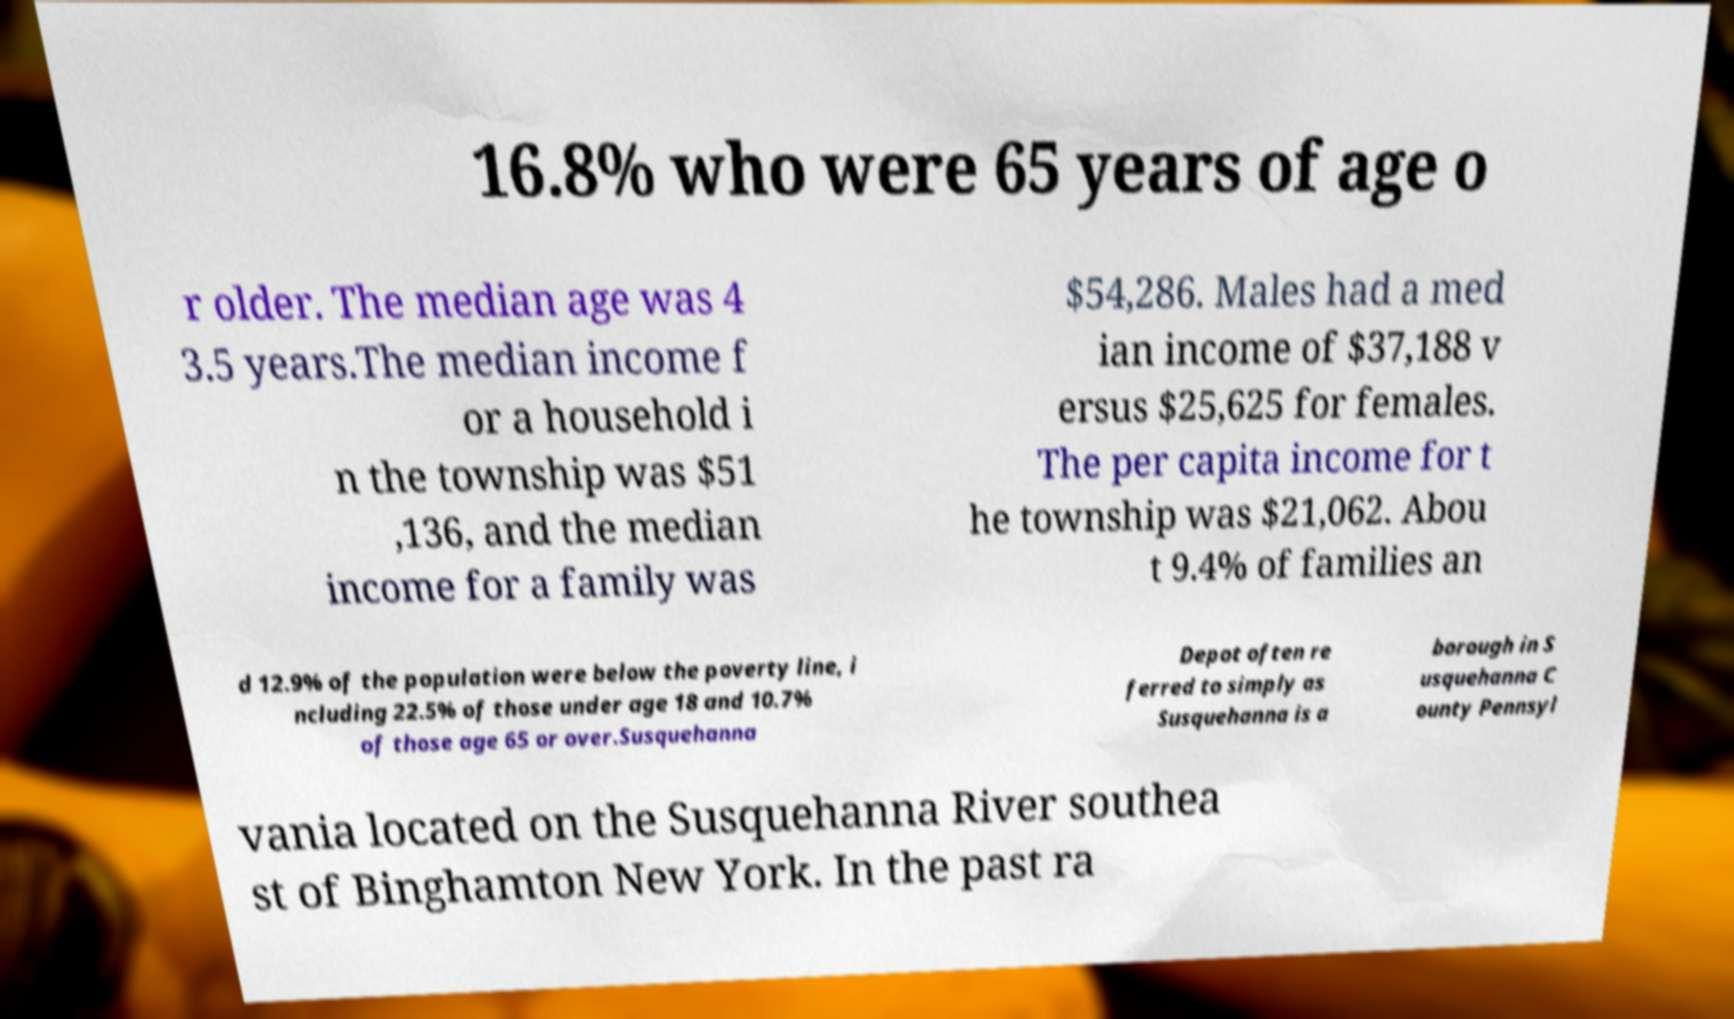Please read and relay the text visible in this image. What does it say? 16.8% who were 65 years of age o r older. The median age was 4 3.5 years.The median income f or a household i n the township was $51 ,136, and the median income for a family was $54,286. Males had a med ian income of $37,188 v ersus $25,625 for females. The per capita income for t he township was $21,062. Abou t 9.4% of families an d 12.9% of the population were below the poverty line, i ncluding 22.5% of those under age 18 and 10.7% of those age 65 or over.Susquehanna Depot often re ferred to simply as Susquehanna is a borough in S usquehanna C ounty Pennsyl vania located on the Susquehanna River southea st of Binghamton New York. In the past ra 